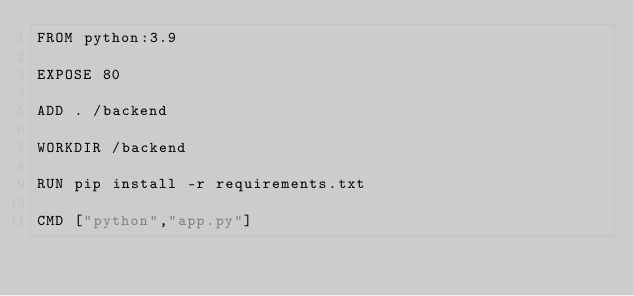Convert code to text. <code><loc_0><loc_0><loc_500><loc_500><_Dockerfile_>FROM python:3.9

EXPOSE 80

ADD . /backend

WORKDIR /backend

RUN pip install -r requirements.txt

CMD ["python","app.py"]
</code> 